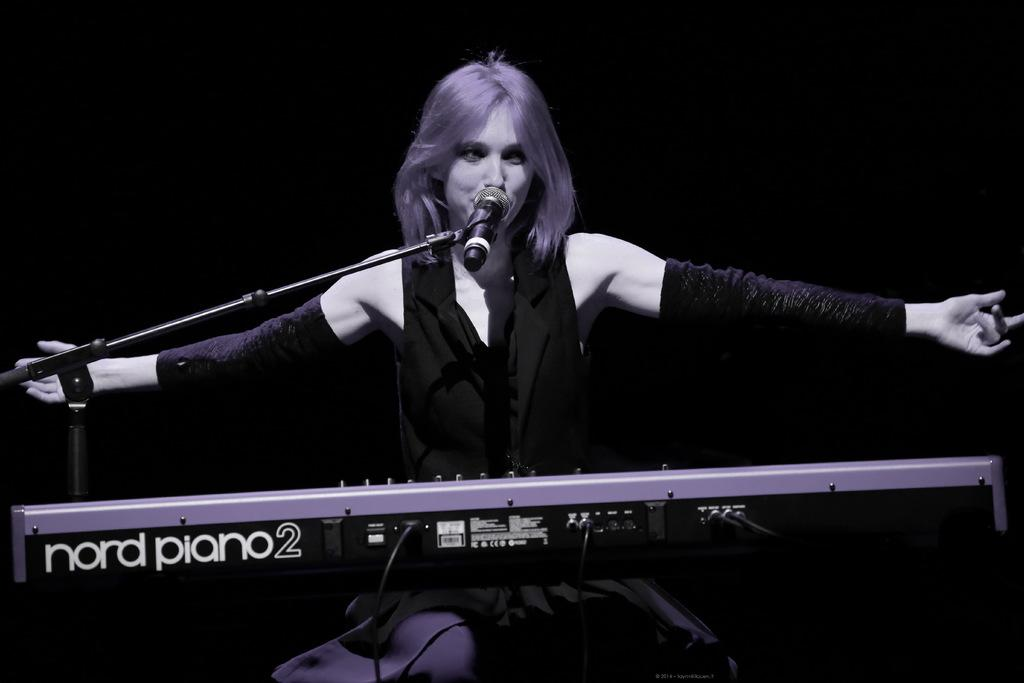What musical instrument is present in the image? There is a piano in the image. Is there any text on the piano? Yes, there is text written on the piano. What other object can be seen in the image? There is a stand in the image. What is on the stand? There is a microphone on the stand. Who is the main subject in the image? There is a woman sitting in the center of the image. What is the woman doing in the image? The woman is singing. What type of spade is being used to dig in the image? There is no spade present in the image; it features a piano, a stand, a microphone, and a woman singing. Can you describe the clouds in the image? There are no clouds visible in the image. 